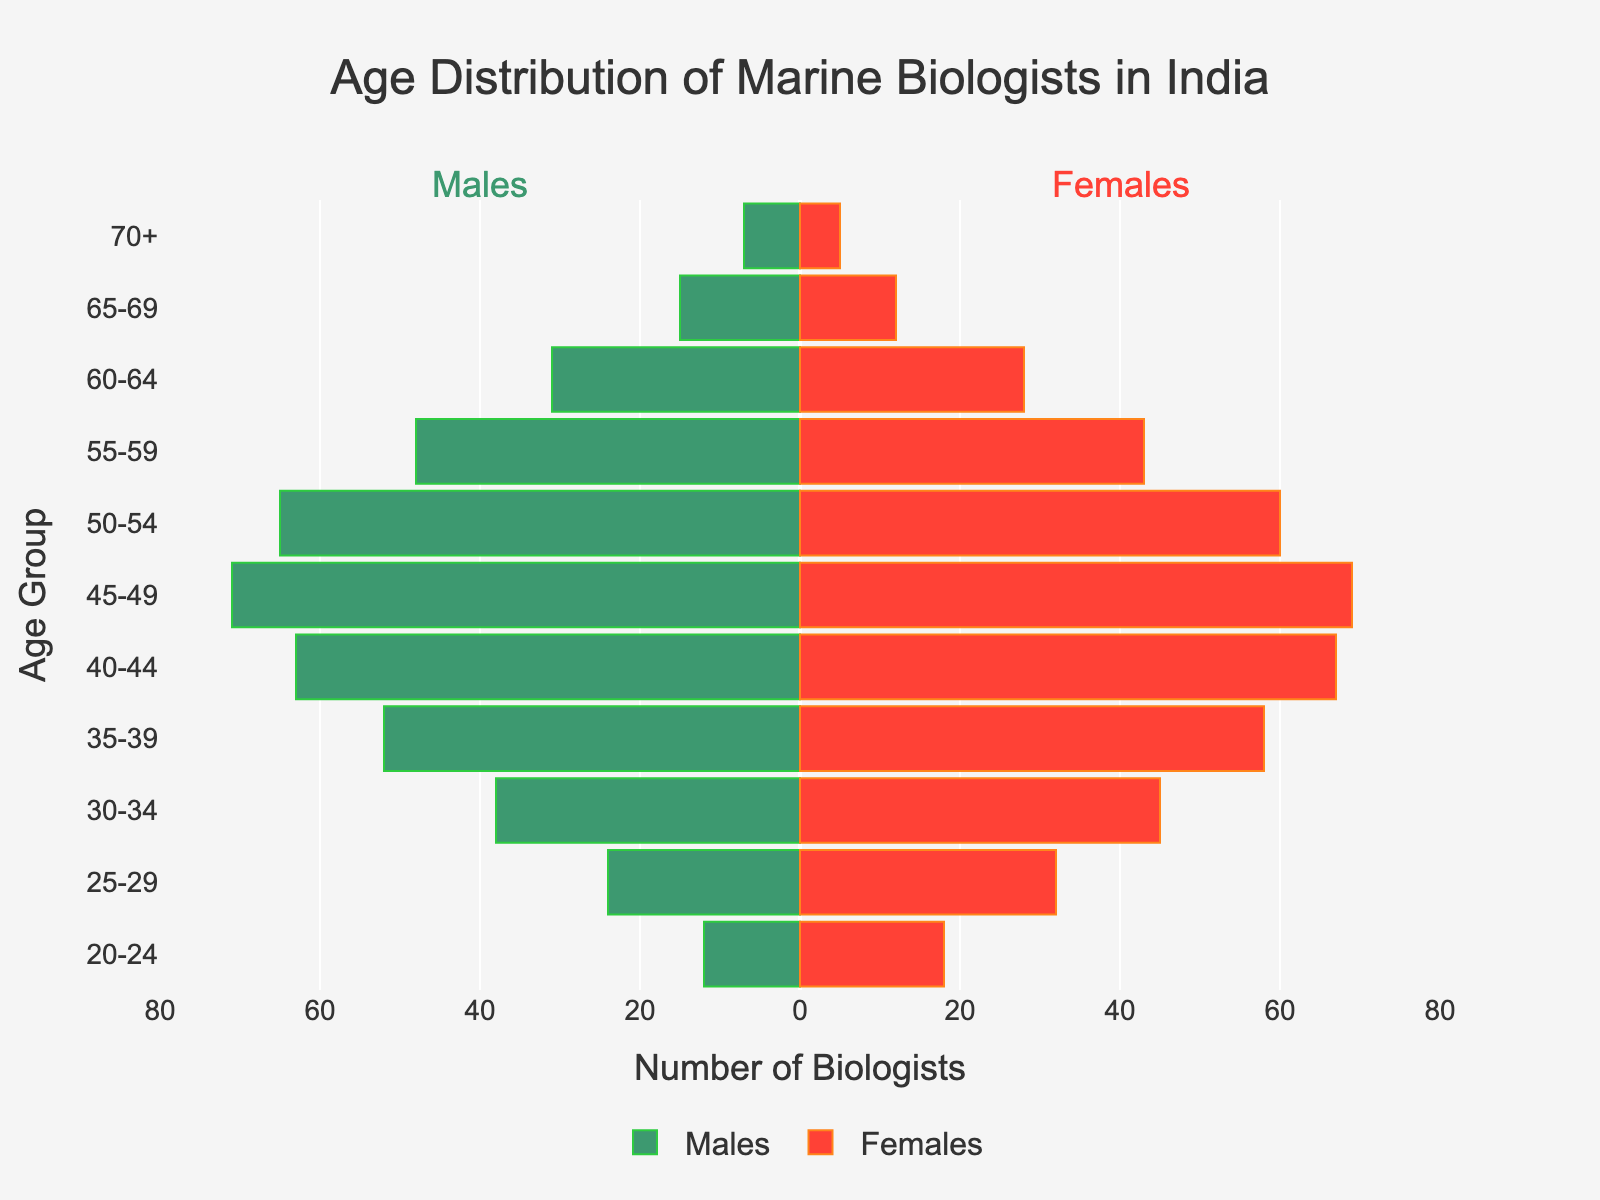Which age group has the highest number of female marine biologists? We look at the female bars in the figure and find that the age group "40-44" has the tallest bar, indicating the highest number of female marine biologists.
Answer: 40-44 How many male marine biologists are in the age group 30-34? We refer to the bar on the left side corresponding to the age group 30-34, which shows 38 male marine biologists.
Answer: 38 What is the total number of marine biologists in the age group 25-29? We sum the values for males and females in the 25-29 age group, which are 24 and 32 respectively, giving us 24 + 32 = 56.
Answer: 56 Which gender has more marine biologists in the age group 50-54? We compare the lengths of the bars for males and females in the age group 50-54. The male bar is longer (65) compared to the female bar (60).
Answer: Males What's the total number of marine biologists aged 55-64? We sum the numbers of males and females in age groups 55-59 and 60-64: (48 + 43) + (31 + 28) equals 79 + 59, which is 138.
Answer: 138 In which age group is the gender disparity the greatest? We find the absolute differences between males and females in each group and see that the largest difference is in the age group "30-34": 45 females and 38 males, so the difference is 7.
Answer: 30-34 What is the ratio of male to female marine biologists in the 35-39 age group? We take the number of males (52) and divide by the number of females (58) to get the ratio: 52 / 58, which simplifies approximately to 0.9.
Answer: 0.9 Count the number of age groups where the number of male marine biologists exceeds that of female marine biologists. We count the age groups where the male bar extends further left than the female bar to the right. These groups are 45-49, 50-54, and 55-59. So, there are three such age groups.
Answer: 3 What is the average number of females across all age groups? We sum all the female values and then divide by the number of age groups (11). The sum of females is 18 + 32 + 45 + 58 + 67 + 69 + 60 + 43 + 28 + 12 + 5 = 437. Dividing by 11, the average is 437 / 11 ≈ 39.73.
Answer: 39.73 